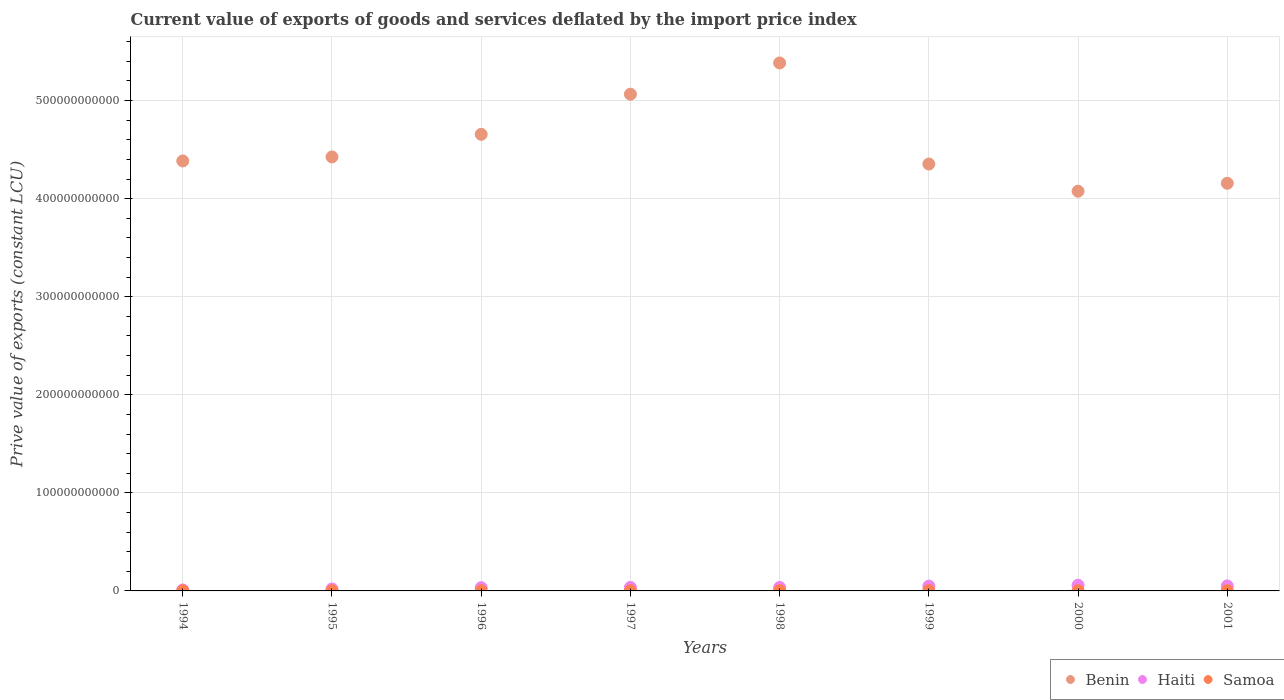How many different coloured dotlines are there?
Offer a terse response. 3. Is the number of dotlines equal to the number of legend labels?
Provide a short and direct response. Yes. What is the prive value of exports in Benin in 1999?
Your answer should be compact. 4.35e+11. Across all years, what is the maximum prive value of exports in Benin?
Make the answer very short. 5.38e+11. Across all years, what is the minimum prive value of exports in Benin?
Ensure brevity in your answer.  4.08e+11. In which year was the prive value of exports in Samoa minimum?
Offer a very short reply. 1994. What is the total prive value of exports in Samoa in the graph?
Provide a short and direct response. 1.95e+09. What is the difference between the prive value of exports in Benin in 1998 and that in 2000?
Provide a short and direct response. 1.31e+11. What is the difference between the prive value of exports in Haiti in 1999 and the prive value of exports in Benin in 1996?
Your answer should be compact. -4.61e+11. What is the average prive value of exports in Haiti per year?
Your answer should be compact. 3.65e+09. In the year 1994, what is the difference between the prive value of exports in Samoa and prive value of exports in Haiti?
Offer a terse response. -8.35e+08. In how many years, is the prive value of exports in Haiti greater than 440000000000 LCU?
Provide a succinct answer. 0. What is the ratio of the prive value of exports in Benin in 1998 to that in 2001?
Ensure brevity in your answer.  1.3. Is the prive value of exports in Samoa in 1997 less than that in 1998?
Ensure brevity in your answer.  Yes. Is the difference between the prive value of exports in Samoa in 1996 and 2000 greater than the difference between the prive value of exports in Haiti in 1996 and 2000?
Give a very brief answer. Yes. What is the difference between the highest and the second highest prive value of exports in Samoa?
Provide a short and direct response. 9.18e+06. What is the difference between the highest and the lowest prive value of exports in Haiti?
Give a very brief answer. 4.82e+09. Is the sum of the prive value of exports in Benin in 1998 and 2000 greater than the maximum prive value of exports in Haiti across all years?
Offer a very short reply. Yes. Does the prive value of exports in Samoa monotonically increase over the years?
Your answer should be compact. No. Is the prive value of exports in Samoa strictly greater than the prive value of exports in Benin over the years?
Your answer should be very brief. No. How many years are there in the graph?
Provide a succinct answer. 8. What is the difference between two consecutive major ticks on the Y-axis?
Offer a very short reply. 1.00e+11. Are the values on the major ticks of Y-axis written in scientific E-notation?
Give a very brief answer. No. Where does the legend appear in the graph?
Ensure brevity in your answer.  Bottom right. What is the title of the graph?
Your answer should be compact. Current value of exports of goods and services deflated by the import price index. What is the label or title of the X-axis?
Ensure brevity in your answer.  Years. What is the label or title of the Y-axis?
Offer a very short reply. Prive value of exports (constant LCU). What is the Prive value of exports (constant LCU) of Benin in 1994?
Offer a very short reply. 4.38e+11. What is the Prive value of exports (constant LCU) in Haiti in 1994?
Your answer should be very brief. 9.75e+08. What is the Prive value of exports (constant LCU) of Samoa in 1994?
Make the answer very short. 1.40e+08. What is the Prive value of exports (constant LCU) of Benin in 1995?
Make the answer very short. 4.43e+11. What is the Prive value of exports (constant LCU) of Haiti in 1995?
Your response must be concise. 2.02e+09. What is the Prive value of exports (constant LCU) of Samoa in 1995?
Your response must be concise. 2.05e+08. What is the Prive value of exports (constant LCU) of Benin in 1996?
Offer a terse response. 4.66e+11. What is the Prive value of exports (constant LCU) in Haiti in 1996?
Your answer should be very brief. 3.30e+09. What is the Prive value of exports (constant LCU) of Samoa in 1996?
Keep it short and to the point. 2.34e+08. What is the Prive value of exports (constant LCU) in Benin in 1997?
Your answer should be compact. 5.07e+11. What is the Prive value of exports (constant LCU) of Haiti in 1997?
Make the answer very short. 3.57e+09. What is the Prive value of exports (constant LCU) in Samoa in 1997?
Your answer should be very brief. 2.44e+08. What is the Prive value of exports (constant LCU) in Benin in 1998?
Your response must be concise. 5.38e+11. What is the Prive value of exports (constant LCU) of Haiti in 1998?
Make the answer very short. 3.58e+09. What is the Prive value of exports (constant LCU) of Samoa in 1998?
Keep it short and to the point. 2.86e+08. What is the Prive value of exports (constant LCU) of Benin in 1999?
Offer a terse response. 4.35e+11. What is the Prive value of exports (constant LCU) in Haiti in 1999?
Offer a terse response. 4.87e+09. What is the Prive value of exports (constant LCU) of Samoa in 1999?
Keep it short and to the point. 2.95e+08. What is the Prive value of exports (constant LCU) of Benin in 2000?
Make the answer very short. 4.08e+11. What is the Prive value of exports (constant LCU) of Haiti in 2000?
Provide a succinct answer. 5.79e+09. What is the Prive value of exports (constant LCU) of Samoa in 2000?
Offer a very short reply. 2.60e+08. What is the Prive value of exports (constant LCU) of Benin in 2001?
Your response must be concise. 4.16e+11. What is the Prive value of exports (constant LCU) of Haiti in 2001?
Give a very brief answer. 5.11e+09. What is the Prive value of exports (constant LCU) of Samoa in 2001?
Offer a very short reply. 2.85e+08. Across all years, what is the maximum Prive value of exports (constant LCU) of Benin?
Offer a terse response. 5.38e+11. Across all years, what is the maximum Prive value of exports (constant LCU) in Haiti?
Offer a very short reply. 5.79e+09. Across all years, what is the maximum Prive value of exports (constant LCU) in Samoa?
Keep it short and to the point. 2.95e+08. Across all years, what is the minimum Prive value of exports (constant LCU) in Benin?
Ensure brevity in your answer.  4.08e+11. Across all years, what is the minimum Prive value of exports (constant LCU) in Haiti?
Provide a short and direct response. 9.75e+08. Across all years, what is the minimum Prive value of exports (constant LCU) of Samoa?
Your response must be concise. 1.40e+08. What is the total Prive value of exports (constant LCU) of Benin in the graph?
Keep it short and to the point. 3.65e+12. What is the total Prive value of exports (constant LCU) of Haiti in the graph?
Your response must be concise. 2.92e+1. What is the total Prive value of exports (constant LCU) of Samoa in the graph?
Provide a succinct answer. 1.95e+09. What is the difference between the Prive value of exports (constant LCU) in Benin in 1994 and that in 1995?
Offer a very short reply. -4.11e+09. What is the difference between the Prive value of exports (constant LCU) of Haiti in 1994 and that in 1995?
Keep it short and to the point. -1.04e+09. What is the difference between the Prive value of exports (constant LCU) in Samoa in 1994 and that in 1995?
Provide a succinct answer. -6.46e+07. What is the difference between the Prive value of exports (constant LCU) of Benin in 1994 and that in 1996?
Provide a succinct answer. -2.72e+1. What is the difference between the Prive value of exports (constant LCU) in Haiti in 1994 and that in 1996?
Provide a succinct answer. -2.32e+09. What is the difference between the Prive value of exports (constant LCU) of Samoa in 1994 and that in 1996?
Your answer should be compact. -9.42e+07. What is the difference between the Prive value of exports (constant LCU) in Benin in 1994 and that in 1997?
Keep it short and to the point. -6.81e+1. What is the difference between the Prive value of exports (constant LCU) of Haiti in 1994 and that in 1997?
Make the answer very short. -2.59e+09. What is the difference between the Prive value of exports (constant LCU) in Samoa in 1994 and that in 1997?
Offer a very short reply. -1.04e+08. What is the difference between the Prive value of exports (constant LCU) in Benin in 1994 and that in 1998?
Your response must be concise. -9.99e+1. What is the difference between the Prive value of exports (constant LCU) in Haiti in 1994 and that in 1998?
Keep it short and to the point. -2.60e+09. What is the difference between the Prive value of exports (constant LCU) in Samoa in 1994 and that in 1998?
Give a very brief answer. -1.46e+08. What is the difference between the Prive value of exports (constant LCU) of Benin in 1994 and that in 1999?
Offer a very short reply. 3.13e+09. What is the difference between the Prive value of exports (constant LCU) in Haiti in 1994 and that in 1999?
Make the answer very short. -3.89e+09. What is the difference between the Prive value of exports (constant LCU) in Samoa in 1994 and that in 1999?
Your answer should be very brief. -1.55e+08. What is the difference between the Prive value of exports (constant LCU) of Benin in 1994 and that in 2000?
Your answer should be compact. 3.09e+1. What is the difference between the Prive value of exports (constant LCU) in Haiti in 1994 and that in 2000?
Provide a succinct answer. -4.82e+09. What is the difference between the Prive value of exports (constant LCU) in Samoa in 1994 and that in 2000?
Make the answer very short. -1.20e+08. What is the difference between the Prive value of exports (constant LCU) of Benin in 1994 and that in 2001?
Provide a succinct answer. 2.28e+1. What is the difference between the Prive value of exports (constant LCU) in Haiti in 1994 and that in 2001?
Ensure brevity in your answer.  -4.13e+09. What is the difference between the Prive value of exports (constant LCU) in Samoa in 1994 and that in 2001?
Your answer should be compact. -1.45e+08. What is the difference between the Prive value of exports (constant LCU) in Benin in 1995 and that in 1996?
Your response must be concise. -2.30e+1. What is the difference between the Prive value of exports (constant LCU) of Haiti in 1995 and that in 1996?
Ensure brevity in your answer.  -1.28e+09. What is the difference between the Prive value of exports (constant LCU) of Samoa in 1995 and that in 1996?
Your answer should be compact. -2.96e+07. What is the difference between the Prive value of exports (constant LCU) in Benin in 1995 and that in 1997?
Offer a very short reply. -6.40e+1. What is the difference between the Prive value of exports (constant LCU) in Haiti in 1995 and that in 1997?
Provide a short and direct response. -1.55e+09. What is the difference between the Prive value of exports (constant LCU) in Samoa in 1995 and that in 1997?
Provide a succinct answer. -3.93e+07. What is the difference between the Prive value of exports (constant LCU) in Benin in 1995 and that in 1998?
Your response must be concise. -9.58e+1. What is the difference between the Prive value of exports (constant LCU) in Haiti in 1995 and that in 1998?
Your response must be concise. -1.56e+09. What is the difference between the Prive value of exports (constant LCU) in Samoa in 1995 and that in 1998?
Ensure brevity in your answer.  -8.15e+07. What is the difference between the Prive value of exports (constant LCU) in Benin in 1995 and that in 1999?
Provide a short and direct response. 7.24e+09. What is the difference between the Prive value of exports (constant LCU) of Haiti in 1995 and that in 1999?
Give a very brief answer. -2.85e+09. What is the difference between the Prive value of exports (constant LCU) in Samoa in 1995 and that in 1999?
Make the answer very short. -9.07e+07. What is the difference between the Prive value of exports (constant LCU) of Benin in 1995 and that in 2000?
Offer a very short reply. 3.50e+1. What is the difference between the Prive value of exports (constant LCU) of Haiti in 1995 and that in 2000?
Offer a terse response. -3.78e+09. What is the difference between the Prive value of exports (constant LCU) in Samoa in 1995 and that in 2000?
Your answer should be very brief. -5.55e+07. What is the difference between the Prive value of exports (constant LCU) in Benin in 1995 and that in 2001?
Your response must be concise. 2.69e+1. What is the difference between the Prive value of exports (constant LCU) of Haiti in 1995 and that in 2001?
Make the answer very short. -3.09e+09. What is the difference between the Prive value of exports (constant LCU) of Samoa in 1995 and that in 2001?
Ensure brevity in your answer.  -8.03e+07. What is the difference between the Prive value of exports (constant LCU) in Benin in 1996 and that in 1997?
Your answer should be compact. -4.09e+1. What is the difference between the Prive value of exports (constant LCU) in Haiti in 1996 and that in 1997?
Make the answer very short. -2.68e+08. What is the difference between the Prive value of exports (constant LCU) in Samoa in 1996 and that in 1997?
Your answer should be compact. -9.63e+06. What is the difference between the Prive value of exports (constant LCU) of Benin in 1996 and that in 1998?
Your answer should be very brief. -7.28e+1. What is the difference between the Prive value of exports (constant LCU) in Haiti in 1996 and that in 1998?
Your response must be concise. -2.78e+08. What is the difference between the Prive value of exports (constant LCU) in Samoa in 1996 and that in 1998?
Keep it short and to the point. -5.19e+07. What is the difference between the Prive value of exports (constant LCU) of Benin in 1996 and that in 1999?
Offer a terse response. 3.03e+1. What is the difference between the Prive value of exports (constant LCU) of Haiti in 1996 and that in 1999?
Your answer should be very brief. -1.57e+09. What is the difference between the Prive value of exports (constant LCU) in Samoa in 1996 and that in 1999?
Offer a terse response. -6.11e+07. What is the difference between the Prive value of exports (constant LCU) of Benin in 1996 and that in 2000?
Your response must be concise. 5.80e+1. What is the difference between the Prive value of exports (constant LCU) in Haiti in 1996 and that in 2000?
Offer a terse response. -2.50e+09. What is the difference between the Prive value of exports (constant LCU) of Samoa in 1996 and that in 2000?
Your answer should be very brief. -2.59e+07. What is the difference between the Prive value of exports (constant LCU) of Benin in 1996 and that in 2001?
Give a very brief answer. 4.99e+1. What is the difference between the Prive value of exports (constant LCU) in Haiti in 1996 and that in 2001?
Give a very brief answer. -1.81e+09. What is the difference between the Prive value of exports (constant LCU) of Samoa in 1996 and that in 2001?
Provide a short and direct response. -5.07e+07. What is the difference between the Prive value of exports (constant LCU) in Benin in 1997 and that in 1998?
Your response must be concise. -3.19e+1. What is the difference between the Prive value of exports (constant LCU) of Haiti in 1997 and that in 1998?
Provide a succinct answer. -1.03e+07. What is the difference between the Prive value of exports (constant LCU) of Samoa in 1997 and that in 1998?
Give a very brief answer. -4.23e+07. What is the difference between the Prive value of exports (constant LCU) in Benin in 1997 and that in 1999?
Offer a terse response. 7.12e+1. What is the difference between the Prive value of exports (constant LCU) in Haiti in 1997 and that in 1999?
Offer a very short reply. -1.30e+09. What is the difference between the Prive value of exports (constant LCU) of Samoa in 1997 and that in 1999?
Offer a terse response. -5.15e+07. What is the difference between the Prive value of exports (constant LCU) of Benin in 1997 and that in 2000?
Your response must be concise. 9.89e+1. What is the difference between the Prive value of exports (constant LCU) of Haiti in 1997 and that in 2000?
Provide a succinct answer. -2.23e+09. What is the difference between the Prive value of exports (constant LCU) of Samoa in 1997 and that in 2000?
Ensure brevity in your answer.  -1.63e+07. What is the difference between the Prive value of exports (constant LCU) in Benin in 1997 and that in 2001?
Provide a succinct answer. 9.08e+1. What is the difference between the Prive value of exports (constant LCU) in Haiti in 1997 and that in 2001?
Make the answer very short. -1.54e+09. What is the difference between the Prive value of exports (constant LCU) in Samoa in 1997 and that in 2001?
Make the answer very short. -4.10e+07. What is the difference between the Prive value of exports (constant LCU) in Benin in 1998 and that in 1999?
Offer a very short reply. 1.03e+11. What is the difference between the Prive value of exports (constant LCU) in Haiti in 1998 and that in 1999?
Offer a terse response. -1.29e+09. What is the difference between the Prive value of exports (constant LCU) of Samoa in 1998 and that in 1999?
Offer a terse response. -9.18e+06. What is the difference between the Prive value of exports (constant LCU) in Benin in 1998 and that in 2000?
Your response must be concise. 1.31e+11. What is the difference between the Prive value of exports (constant LCU) in Haiti in 1998 and that in 2000?
Your answer should be compact. -2.22e+09. What is the difference between the Prive value of exports (constant LCU) of Samoa in 1998 and that in 2000?
Make the answer very short. 2.60e+07. What is the difference between the Prive value of exports (constant LCU) of Benin in 1998 and that in 2001?
Offer a terse response. 1.23e+11. What is the difference between the Prive value of exports (constant LCU) in Haiti in 1998 and that in 2001?
Provide a succinct answer. -1.53e+09. What is the difference between the Prive value of exports (constant LCU) of Samoa in 1998 and that in 2001?
Your answer should be very brief. 1.26e+06. What is the difference between the Prive value of exports (constant LCU) in Benin in 1999 and that in 2000?
Your answer should be very brief. 2.77e+1. What is the difference between the Prive value of exports (constant LCU) of Haiti in 1999 and that in 2000?
Provide a succinct answer. -9.28e+08. What is the difference between the Prive value of exports (constant LCU) of Samoa in 1999 and that in 2000?
Provide a short and direct response. 3.52e+07. What is the difference between the Prive value of exports (constant LCU) of Benin in 1999 and that in 2001?
Provide a short and direct response. 1.96e+1. What is the difference between the Prive value of exports (constant LCU) of Haiti in 1999 and that in 2001?
Offer a terse response. -2.42e+08. What is the difference between the Prive value of exports (constant LCU) of Samoa in 1999 and that in 2001?
Make the answer very short. 1.04e+07. What is the difference between the Prive value of exports (constant LCU) in Benin in 2000 and that in 2001?
Your answer should be very brief. -8.10e+09. What is the difference between the Prive value of exports (constant LCU) in Haiti in 2000 and that in 2001?
Provide a short and direct response. 6.86e+08. What is the difference between the Prive value of exports (constant LCU) in Samoa in 2000 and that in 2001?
Offer a terse response. -2.48e+07. What is the difference between the Prive value of exports (constant LCU) of Benin in 1994 and the Prive value of exports (constant LCU) of Haiti in 1995?
Offer a very short reply. 4.36e+11. What is the difference between the Prive value of exports (constant LCU) in Benin in 1994 and the Prive value of exports (constant LCU) in Samoa in 1995?
Ensure brevity in your answer.  4.38e+11. What is the difference between the Prive value of exports (constant LCU) in Haiti in 1994 and the Prive value of exports (constant LCU) in Samoa in 1995?
Keep it short and to the point. 7.70e+08. What is the difference between the Prive value of exports (constant LCU) in Benin in 1994 and the Prive value of exports (constant LCU) in Haiti in 1996?
Offer a terse response. 4.35e+11. What is the difference between the Prive value of exports (constant LCU) in Benin in 1994 and the Prive value of exports (constant LCU) in Samoa in 1996?
Give a very brief answer. 4.38e+11. What is the difference between the Prive value of exports (constant LCU) of Haiti in 1994 and the Prive value of exports (constant LCU) of Samoa in 1996?
Provide a short and direct response. 7.40e+08. What is the difference between the Prive value of exports (constant LCU) of Benin in 1994 and the Prive value of exports (constant LCU) of Haiti in 1997?
Keep it short and to the point. 4.35e+11. What is the difference between the Prive value of exports (constant LCU) in Benin in 1994 and the Prive value of exports (constant LCU) in Samoa in 1997?
Provide a succinct answer. 4.38e+11. What is the difference between the Prive value of exports (constant LCU) in Haiti in 1994 and the Prive value of exports (constant LCU) in Samoa in 1997?
Keep it short and to the point. 7.31e+08. What is the difference between the Prive value of exports (constant LCU) of Benin in 1994 and the Prive value of exports (constant LCU) of Haiti in 1998?
Provide a succinct answer. 4.35e+11. What is the difference between the Prive value of exports (constant LCU) of Benin in 1994 and the Prive value of exports (constant LCU) of Samoa in 1998?
Ensure brevity in your answer.  4.38e+11. What is the difference between the Prive value of exports (constant LCU) in Haiti in 1994 and the Prive value of exports (constant LCU) in Samoa in 1998?
Your response must be concise. 6.88e+08. What is the difference between the Prive value of exports (constant LCU) of Benin in 1994 and the Prive value of exports (constant LCU) of Haiti in 1999?
Your answer should be compact. 4.34e+11. What is the difference between the Prive value of exports (constant LCU) in Benin in 1994 and the Prive value of exports (constant LCU) in Samoa in 1999?
Provide a short and direct response. 4.38e+11. What is the difference between the Prive value of exports (constant LCU) of Haiti in 1994 and the Prive value of exports (constant LCU) of Samoa in 1999?
Provide a succinct answer. 6.79e+08. What is the difference between the Prive value of exports (constant LCU) of Benin in 1994 and the Prive value of exports (constant LCU) of Haiti in 2000?
Provide a short and direct response. 4.33e+11. What is the difference between the Prive value of exports (constant LCU) in Benin in 1994 and the Prive value of exports (constant LCU) in Samoa in 2000?
Make the answer very short. 4.38e+11. What is the difference between the Prive value of exports (constant LCU) of Haiti in 1994 and the Prive value of exports (constant LCU) of Samoa in 2000?
Make the answer very short. 7.14e+08. What is the difference between the Prive value of exports (constant LCU) in Benin in 1994 and the Prive value of exports (constant LCU) in Haiti in 2001?
Offer a very short reply. 4.33e+11. What is the difference between the Prive value of exports (constant LCU) of Benin in 1994 and the Prive value of exports (constant LCU) of Samoa in 2001?
Give a very brief answer. 4.38e+11. What is the difference between the Prive value of exports (constant LCU) in Haiti in 1994 and the Prive value of exports (constant LCU) in Samoa in 2001?
Provide a succinct answer. 6.90e+08. What is the difference between the Prive value of exports (constant LCU) of Benin in 1995 and the Prive value of exports (constant LCU) of Haiti in 1996?
Provide a short and direct response. 4.39e+11. What is the difference between the Prive value of exports (constant LCU) of Benin in 1995 and the Prive value of exports (constant LCU) of Samoa in 1996?
Ensure brevity in your answer.  4.42e+11. What is the difference between the Prive value of exports (constant LCU) of Haiti in 1995 and the Prive value of exports (constant LCU) of Samoa in 1996?
Provide a short and direct response. 1.78e+09. What is the difference between the Prive value of exports (constant LCU) in Benin in 1995 and the Prive value of exports (constant LCU) in Haiti in 1997?
Your answer should be compact. 4.39e+11. What is the difference between the Prive value of exports (constant LCU) of Benin in 1995 and the Prive value of exports (constant LCU) of Samoa in 1997?
Your answer should be very brief. 4.42e+11. What is the difference between the Prive value of exports (constant LCU) of Haiti in 1995 and the Prive value of exports (constant LCU) of Samoa in 1997?
Offer a terse response. 1.77e+09. What is the difference between the Prive value of exports (constant LCU) of Benin in 1995 and the Prive value of exports (constant LCU) of Haiti in 1998?
Give a very brief answer. 4.39e+11. What is the difference between the Prive value of exports (constant LCU) in Benin in 1995 and the Prive value of exports (constant LCU) in Samoa in 1998?
Make the answer very short. 4.42e+11. What is the difference between the Prive value of exports (constant LCU) of Haiti in 1995 and the Prive value of exports (constant LCU) of Samoa in 1998?
Your answer should be compact. 1.73e+09. What is the difference between the Prive value of exports (constant LCU) in Benin in 1995 and the Prive value of exports (constant LCU) in Haiti in 1999?
Your answer should be compact. 4.38e+11. What is the difference between the Prive value of exports (constant LCU) of Benin in 1995 and the Prive value of exports (constant LCU) of Samoa in 1999?
Keep it short and to the point. 4.42e+11. What is the difference between the Prive value of exports (constant LCU) in Haiti in 1995 and the Prive value of exports (constant LCU) in Samoa in 1999?
Give a very brief answer. 1.72e+09. What is the difference between the Prive value of exports (constant LCU) of Benin in 1995 and the Prive value of exports (constant LCU) of Haiti in 2000?
Keep it short and to the point. 4.37e+11. What is the difference between the Prive value of exports (constant LCU) of Benin in 1995 and the Prive value of exports (constant LCU) of Samoa in 2000?
Give a very brief answer. 4.42e+11. What is the difference between the Prive value of exports (constant LCU) in Haiti in 1995 and the Prive value of exports (constant LCU) in Samoa in 2000?
Give a very brief answer. 1.76e+09. What is the difference between the Prive value of exports (constant LCU) in Benin in 1995 and the Prive value of exports (constant LCU) in Haiti in 2001?
Your response must be concise. 4.37e+11. What is the difference between the Prive value of exports (constant LCU) in Benin in 1995 and the Prive value of exports (constant LCU) in Samoa in 2001?
Ensure brevity in your answer.  4.42e+11. What is the difference between the Prive value of exports (constant LCU) in Haiti in 1995 and the Prive value of exports (constant LCU) in Samoa in 2001?
Your answer should be very brief. 1.73e+09. What is the difference between the Prive value of exports (constant LCU) of Benin in 1996 and the Prive value of exports (constant LCU) of Haiti in 1997?
Offer a very short reply. 4.62e+11. What is the difference between the Prive value of exports (constant LCU) of Benin in 1996 and the Prive value of exports (constant LCU) of Samoa in 1997?
Your answer should be very brief. 4.65e+11. What is the difference between the Prive value of exports (constant LCU) in Haiti in 1996 and the Prive value of exports (constant LCU) in Samoa in 1997?
Provide a succinct answer. 3.05e+09. What is the difference between the Prive value of exports (constant LCU) in Benin in 1996 and the Prive value of exports (constant LCU) in Haiti in 1998?
Ensure brevity in your answer.  4.62e+11. What is the difference between the Prive value of exports (constant LCU) in Benin in 1996 and the Prive value of exports (constant LCU) in Samoa in 1998?
Your answer should be very brief. 4.65e+11. What is the difference between the Prive value of exports (constant LCU) in Haiti in 1996 and the Prive value of exports (constant LCU) in Samoa in 1998?
Ensure brevity in your answer.  3.01e+09. What is the difference between the Prive value of exports (constant LCU) of Benin in 1996 and the Prive value of exports (constant LCU) of Haiti in 1999?
Offer a very short reply. 4.61e+11. What is the difference between the Prive value of exports (constant LCU) in Benin in 1996 and the Prive value of exports (constant LCU) in Samoa in 1999?
Provide a short and direct response. 4.65e+11. What is the difference between the Prive value of exports (constant LCU) in Haiti in 1996 and the Prive value of exports (constant LCU) in Samoa in 1999?
Provide a short and direct response. 3.00e+09. What is the difference between the Prive value of exports (constant LCU) of Benin in 1996 and the Prive value of exports (constant LCU) of Haiti in 2000?
Offer a very short reply. 4.60e+11. What is the difference between the Prive value of exports (constant LCU) of Benin in 1996 and the Prive value of exports (constant LCU) of Samoa in 2000?
Keep it short and to the point. 4.65e+11. What is the difference between the Prive value of exports (constant LCU) of Haiti in 1996 and the Prive value of exports (constant LCU) of Samoa in 2000?
Ensure brevity in your answer.  3.04e+09. What is the difference between the Prive value of exports (constant LCU) in Benin in 1996 and the Prive value of exports (constant LCU) in Haiti in 2001?
Make the answer very short. 4.60e+11. What is the difference between the Prive value of exports (constant LCU) of Benin in 1996 and the Prive value of exports (constant LCU) of Samoa in 2001?
Ensure brevity in your answer.  4.65e+11. What is the difference between the Prive value of exports (constant LCU) in Haiti in 1996 and the Prive value of exports (constant LCU) in Samoa in 2001?
Offer a very short reply. 3.01e+09. What is the difference between the Prive value of exports (constant LCU) in Benin in 1997 and the Prive value of exports (constant LCU) in Haiti in 1998?
Give a very brief answer. 5.03e+11. What is the difference between the Prive value of exports (constant LCU) of Benin in 1997 and the Prive value of exports (constant LCU) of Samoa in 1998?
Make the answer very short. 5.06e+11. What is the difference between the Prive value of exports (constant LCU) in Haiti in 1997 and the Prive value of exports (constant LCU) in Samoa in 1998?
Offer a very short reply. 3.28e+09. What is the difference between the Prive value of exports (constant LCU) in Benin in 1997 and the Prive value of exports (constant LCU) in Haiti in 1999?
Keep it short and to the point. 5.02e+11. What is the difference between the Prive value of exports (constant LCU) of Benin in 1997 and the Prive value of exports (constant LCU) of Samoa in 1999?
Provide a short and direct response. 5.06e+11. What is the difference between the Prive value of exports (constant LCU) in Haiti in 1997 and the Prive value of exports (constant LCU) in Samoa in 1999?
Provide a succinct answer. 3.27e+09. What is the difference between the Prive value of exports (constant LCU) in Benin in 1997 and the Prive value of exports (constant LCU) in Haiti in 2000?
Your response must be concise. 5.01e+11. What is the difference between the Prive value of exports (constant LCU) in Benin in 1997 and the Prive value of exports (constant LCU) in Samoa in 2000?
Your response must be concise. 5.06e+11. What is the difference between the Prive value of exports (constant LCU) in Haiti in 1997 and the Prive value of exports (constant LCU) in Samoa in 2000?
Provide a succinct answer. 3.31e+09. What is the difference between the Prive value of exports (constant LCU) in Benin in 1997 and the Prive value of exports (constant LCU) in Haiti in 2001?
Offer a very short reply. 5.01e+11. What is the difference between the Prive value of exports (constant LCU) of Benin in 1997 and the Prive value of exports (constant LCU) of Samoa in 2001?
Provide a short and direct response. 5.06e+11. What is the difference between the Prive value of exports (constant LCU) in Haiti in 1997 and the Prive value of exports (constant LCU) in Samoa in 2001?
Your answer should be very brief. 3.28e+09. What is the difference between the Prive value of exports (constant LCU) of Benin in 1998 and the Prive value of exports (constant LCU) of Haiti in 1999?
Provide a succinct answer. 5.33e+11. What is the difference between the Prive value of exports (constant LCU) of Benin in 1998 and the Prive value of exports (constant LCU) of Samoa in 1999?
Your response must be concise. 5.38e+11. What is the difference between the Prive value of exports (constant LCU) of Haiti in 1998 and the Prive value of exports (constant LCU) of Samoa in 1999?
Offer a terse response. 3.28e+09. What is the difference between the Prive value of exports (constant LCU) in Benin in 1998 and the Prive value of exports (constant LCU) in Haiti in 2000?
Provide a short and direct response. 5.33e+11. What is the difference between the Prive value of exports (constant LCU) in Benin in 1998 and the Prive value of exports (constant LCU) in Samoa in 2000?
Keep it short and to the point. 5.38e+11. What is the difference between the Prive value of exports (constant LCU) of Haiti in 1998 and the Prive value of exports (constant LCU) of Samoa in 2000?
Provide a succinct answer. 3.32e+09. What is the difference between the Prive value of exports (constant LCU) in Benin in 1998 and the Prive value of exports (constant LCU) in Haiti in 2001?
Make the answer very short. 5.33e+11. What is the difference between the Prive value of exports (constant LCU) in Benin in 1998 and the Prive value of exports (constant LCU) in Samoa in 2001?
Provide a short and direct response. 5.38e+11. What is the difference between the Prive value of exports (constant LCU) in Haiti in 1998 and the Prive value of exports (constant LCU) in Samoa in 2001?
Make the answer very short. 3.29e+09. What is the difference between the Prive value of exports (constant LCU) of Benin in 1999 and the Prive value of exports (constant LCU) of Haiti in 2000?
Provide a succinct answer. 4.30e+11. What is the difference between the Prive value of exports (constant LCU) in Benin in 1999 and the Prive value of exports (constant LCU) in Samoa in 2000?
Ensure brevity in your answer.  4.35e+11. What is the difference between the Prive value of exports (constant LCU) of Haiti in 1999 and the Prive value of exports (constant LCU) of Samoa in 2000?
Provide a short and direct response. 4.61e+09. What is the difference between the Prive value of exports (constant LCU) of Benin in 1999 and the Prive value of exports (constant LCU) of Haiti in 2001?
Offer a very short reply. 4.30e+11. What is the difference between the Prive value of exports (constant LCU) of Benin in 1999 and the Prive value of exports (constant LCU) of Samoa in 2001?
Provide a short and direct response. 4.35e+11. What is the difference between the Prive value of exports (constant LCU) in Haiti in 1999 and the Prive value of exports (constant LCU) in Samoa in 2001?
Make the answer very short. 4.58e+09. What is the difference between the Prive value of exports (constant LCU) of Benin in 2000 and the Prive value of exports (constant LCU) of Haiti in 2001?
Your response must be concise. 4.02e+11. What is the difference between the Prive value of exports (constant LCU) of Benin in 2000 and the Prive value of exports (constant LCU) of Samoa in 2001?
Provide a succinct answer. 4.07e+11. What is the difference between the Prive value of exports (constant LCU) of Haiti in 2000 and the Prive value of exports (constant LCU) of Samoa in 2001?
Your answer should be very brief. 5.51e+09. What is the average Prive value of exports (constant LCU) of Benin per year?
Your answer should be compact. 4.56e+11. What is the average Prive value of exports (constant LCU) in Haiti per year?
Your answer should be very brief. 3.65e+09. What is the average Prive value of exports (constant LCU) in Samoa per year?
Offer a very short reply. 2.44e+08. In the year 1994, what is the difference between the Prive value of exports (constant LCU) in Benin and Prive value of exports (constant LCU) in Haiti?
Keep it short and to the point. 4.37e+11. In the year 1994, what is the difference between the Prive value of exports (constant LCU) of Benin and Prive value of exports (constant LCU) of Samoa?
Keep it short and to the point. 4.38e+11. In the year 1994, what is the difference between the Prive value of exports (constant LCU) in Haiti and Prive value of exports (constant LCU) in Samoa?
Give a very brief answer. 8.35e+08. In the year 1995, what is the difference between the Prive value of exports (constant LCU) in Benin and Prive value of exports (constant LCU) in Haiti?
Give a very brief answer. 4.41e+11. In the year 1995, what is the difference between the Prive value of exports (constant LCU) of Benin and Prive value of exports (constant LCU) of Samoa?
Offer a very short reply. 4.42e+11. In the year 1995, what is the difference between the Prive value of exports (constant LCU) in Haiti and Prive value of exports (constant LCU) in Samoa?
Offer a terse response. 1.81e+09. In the year 1996, what is the difference between the Prive value of exports (constant LCU) of Benin and Prive value of exports (constant LCU) of Haiti?
Your answer should be very brief. 4.62e+11. In the year 1996, what is the difference between the Prive value of exports (constant LCU) of Benin and Prive value of exports (constant LCU) of Samoa?
Your response must be concise. 4.65e+11. In the year 1996, what is the difference between the Prive value of exports (constant LCU) of Haiti and Prive value of exports (constant LCU) of Samoa?
Keep it short and to the point. 3.06e+09. In the year 1997, what is the difference between the Prive value of exports (constant LCU) in Benin and Prive value of exports (constant LCU) in Haiti?
Provide a succinct answer. 5.03e+11. In the year 1997, what is the difference between the Prive value of exports (constant LCU) in Benin and Prive value of exports (constant LCU) in Samoa?
Your response must be concise. 5.06e+11. In the year 1997, what is the difference between the Prive value of exports (constant LCU) of Haiti and Prive value of exports (constant LCU) of Samoa?
Ensure brevity in your answer.  3.32e+09. In the year 1998, what is the difference between the Prive value of exports (constant LCU) in Benin and Prive value of exports (constant LCU) in Haiti?
Your answer should be very brief. 5.35e+11. In the year 1998, what is the difference between the Prive value of exports (constant LCU) in Benin and Prive value of exports (constant LCU) in Samoa?
Provide a short and direct response. 5.38e+11. In the year 1998, what is the difference between the Prive value of exports (constant LCU) in Haiti and Prive value of exports (constant LCU) in Samoa?
Make the answer very short. 3.29e+09. In the year 1999, what is the difference between the Prive value of exports (constant LCU) in Benin and Prive value of exports (constant LCU) in Haiti?
Your response must be concise. 4.30e+11. In the year 1999, what is the difference between the Prive value of exports (constant LCU) in Benin and Prive value of exports (constant LCU) in Samoa?
Keep it short and to the point. 4.35e+11. In the year 1999, what is the difference between the Prive value of exports (constant LCU) of Haiti and Prive value of exports (constant LCU) of Samoa?
Keep it short and to the point. 4.57e+09. In the year 2000, what is the difference between the Prive value of exports (constant LCU) of Benin and Prive value of exports (constant LCU) of Haiti?
Offer a terse response. 4.02e+11. In the year 2000, what is the difference between the Prive value of exports (constant LCU) of Benin and Prive value of exports (constant LCU) of Samoa?
Offer a terse response. 4.07e+11. In the year 2000, what is the difference between the Prive value of exports (constant LCU) of Haiti and Prive value of exports (constant LCU) of Samoa?
Your response must be concise. 5.53e+09. In the year 2001, what is the difference between the Prive value of exports (constant LCU) in Benin and Prive value of exports (constant LCU) in Haiti?
Keep it short and to the point. 4.11e+11. In the year 2001, what is the difference between the Prive value of exports (constant LCU) in Benin and Prive value of exports (constant LCU) in Samoa?
Give a very brief answer. 4.15e+11. In the year 2001, what is the difference between the Prive value of exports (constant LCU) in Haiti and Prive value of exports (constant LCU) in Samoa?
Make the answer very short. 4.82e+09. What is the ratio of the Prive value of exports (constant LCU) of Benin in 1994 to that in 1995?
Provide a succinct answer. 0.99. What is the ratio of the Prive value of exports (constant LCU) of Haiti in 1994 to that in 1995?
Your answer should be very brief. 0.48. What is the ratio of the Prive value of exports (constant LCU) of Samoa in 1994 to that in 1995?
Make the answer very short. 0.68. What is the ratio of the Prive value of exports (constant LCU) of Benin in 1994 to that in 1996?
Provide a succinct answer. 0.94. What is the ratio of the Prive value of exports (constant LCU) in Haiti in 1994 to that in 1996?
Your answer should be compact. 0.3. What is the ratio of the Prive value of exports (constant LCU) in Samoa in 1994 to that in 1996?
Keep it short and to the point. 0.6. What is the ratio of the Prive value of exports (constant LCU) in Benin in 1994 to that in 1997?
Your answer should be compact. 0.87. What is the ratio of the Prive value of exports (constant LCU) of Haiti in 1994 to that in 1997?
Offer a very short reply. 0.27. What is the ratio of the Prive value of exports (constant LCU) in Samoa in 1994 to that in 1997?
Provide a short and direct response. 0.57. What is the ratio of the Prive value of exports (constant LCU) in Benin in 1994 to that in 1998?
Provide a short and direct response. 0.81. What is the ratio of the Prive value of exports (constant LCU) in Haiti in 1994 to that in 1998?
Give a very brief answer. 0.27. What is the ratio of the Prive value of exports (constant LCU) in Samoa in 1994 to that in 1998?
Give a very brief answer. 0.49. What is the ratio of the Prive value of exports (constant LCU) of Haiti in 1994 to that in 1999?
Make the answer very short. 0.2. What is the ratio of the Prive value of exports (constant LCU) of Samoa in 1994 to that in 1999?
Provide a short and direct response. 0.47. What is the ratio of the Prive value of exports (constant LCU) in Benin in 1994 to that in 2000?
Provide a short and direct response. 1.08. What is the ratio of the Prive value of exports (constant LCU) of Haiti in 1994 to that in 2000?
Make the answer very short. 0.17. What is the ratio of the Prive value of exports (constant LCU) of Samoa in 1994 to that in 2000?
Keep it short and to the point. 0.54. What is the ratio of the Prive value of exports (constant LCU) of Benin in 1994 to that in 2001?
Give a very brief answer. 1.05. What is the ratio of the Prive value of exports (constant LCU) in Haiti in 1994 to that in 2001?
Your answer should be very brief. 0.19. What is the ratio of the Prive value of exports (constant LCU) in Samoa in 1994 to that in 2001?
Keep it short and to the point. 0.49. What is the ratio of the Prive value of exports (constant LCU) in Benin in 1995 to that in 1996?
Offer a very short reply. 0.95. What is the ratio of the Prive value of exports (constant LCU) in Haiti in 1995 to that in 1996?
Offer a very short reply. 0.61. What is the ratio of the Prive value of exports (constant LCU) of Samoa in 1995 to that in 1996?
Your answer should be compact. 0.87. What is the ratio of the Prive value of exports (constant LCU) in Benin in 1995 to that in 1997?
Your answer should be very brief. 0.87. What is the ratio of the Prive value of exports (constant LCU) in Haiti in 1995 to that in 1997?
Keep it short and to the point. 0.57. What is the ratio of the Prive value of exports (constant LCU) in Samoa in 1995 to that in 1997?
Offer a very short reply. 0.84. What is the ratio of the Prive value of exports (constant LCU) in Benin in 1995 to that in 1998?
Offer a terse response. 0.82. What is the ratio of the Prive value of exports (constant LCU) of Haiti in 1995 to that in 1998?
Give a very brief answer. 0.56. What is the ratio of the Prive value of exports (constant LCU) of Samoa in 1995 to that in 1998?
Provide a short and direct response. 0.72. What is the ratio of the Prive value of exports (constant LCU) in Benin in 1995 to that in 1999?
Provide a succinct answer. 1.02. What is the ratio of the Prive value of exports (constant LCU) in Haiti in 1995 to that in 1999?
Offer a terse response. 0.41. What is the ratio of the Prive value of exports (constant LCU) of Samoa in 1995 to that in 1999?
Ensure brevity in your answer.  0.69. What is the ratio of the Prive value of exports (constant LCU) of Benin in 1995 to that in 2000?
Provide a succinct answer. 1.09. What is the ratio of the Prive value of exports (constant LCU) of Haiti in 1995 to that in 2000?
Keep it short and to the point. 0.35. What is the ratio of the Prive value of exports (constant LCU) in Samoa in 1995 to that in 2000?
Your response must be concise. 0.79. What is the ratio of the Prive value of exports (constant LCU) of Benin in 1995 to that in 2001?
Offer a very short reply. 1.06. What is the ratio of the Prive value of exports (constant LCU) of Haiti in 1995 to that in 2001?
Your answer should be very brief. 0.4. What is the ratio of the Prive value of exports (constant LCU) in Samoa in 1995 to that in 2001?
Your answer should be compact. 0.72. What is the ratio of the Prive value of exports (constant LCU) of Benin in 1996 to that in 1997?
Your response must be concise. 0.92. What is the ratio of the Prive value of exports (constant LCU) of Haiti in 1996 to that in 1997?
Keep it short and to the point. 0.92. What is the ratio of the Prive value of exports (constant LCU) in Samoa in 1996 to that in 1997?
Your answer should be very brief. 0.96. What is the ratio of the Prive value of exports (constant LCU) of Benin in 1996 to that in 1998?
Provide a short and direct response. 0.86. What is the ratio of the Prive value of exports (constant LCU) of Haiti in 1996 to that in 1998?
Keep it short and to the point. 0.92. What is the ratio of the Prive value of exports (constant LCU) in Samoa in 1996 to that in 1998?
Your answer should be compact. 0.82. What is the ratio of the Prive value of exports (constant LCU) in Benin in 1996 to that in 1999?
Provide a short and direct response. 1.07. What is the ratio of the Prive value of exports (constant LCU) in Haiti in 1996 to that in 1999?
Give a very brief answer. 0.68. What is the ratio of the Prive value of exports (constant LCU) in Samoa in 1996 to that in 1999?
Your answer should be very brief. 0.79. What is the ratio of the Prive value of exports (constant LCU) of Benin in 1996 to that in 2000?
Your answer should be very brief. 1.14. What is the ratio of the Prive value of exports (constant LCU) of Haiti in 1996 to that in 2000?
Your answer should be very brief. 0.57. What is the ratio of the Prive value of exports (constant LCU) of Samoa in 1996 to that in 2000?
Make the answer very short. 0.9. What is the ratio of the Prive value of exports (constant LCU) in Benin in 1996 to that in 2001?
Provide a succinct answer. 1.12. What is the ratio of the Prive value of exports (constant LCU) in Haiti in 1996 to that in 2001?
Offer a very short reply. 0.65. What is the ratio of the Prive value of exports (constant LCU) of Samoa in 1996 to that in 2001?
Ensure brevity in your answer.  0.82. What is the ratio of the Prive value of exports (constant LCU) in Benin in 1997 to that in 1998?
Keep it short and to the point. 0.94. What is the ratio of the Prive value of exports (constant LCU) in Haiti in 1997 to that in 1998?
Your answer should be compact. 1. What is the ratio of the Prive value of exports (constant LCU) in Samoa in 1997 to that in 1998?
Provide a succinct answer. 0.85. What is the ratio of the Prive value of exports (constant LCU) in Benin in 1997 to that in 1999?
Offer a terse response. 1.16. What is the ratio of the Prive value of exports (constant LCU) of Haiti in 1997 to that in 1999?
Provide a short and direct response. 0.73. What is the ratio of the Prive value of exports (constant LCU) of Samoa in 1997 to that in 1999?
Provide a short and direct response. 0.83. What is the ratio of the Prive value of exports (constant LCU) in Benin in 1997 to that in 2000?
Provide a short and direct response. 1.24. What is the ratio of the Prive value of exports (constant LCU) in Haiti in 1997 to that in 2000?
Give a very brief answer. 0.62. What is the ratio of the Prive value of exports (constant LCU) in Samoa in 1997 to that in 2000?
Make the answer very short. 0.94. What is the ratio of the Prive value of exports (constant LCU) in Benin in 1997 to that in 2001?
Provide a short and direct response. 1.22. What is the ratio of the Prive value of exports (constant LCU) of Haiti in 1997 to that in 2001?
Ensure brevity in your answer.  0.7. What is the ratio of the Prive value of exports (constant LCU) of Samoa in 1997 to that in 2001?
Your answer should be compact. 0.86. What is the ratio of the Prive value of exports (constant LCU) in Benin in 1998 to that in 1999?
Provide a succinct answer. 1.24. What is the ratio of the Prive value of exports (constant LCU) in Haiti in 1998 to that in 1999?
Provide a short and direct response. 0.73. What is the ratio of the Prive value of exports (constant LCU) of Samoa in 1998 to that in 1999?
Provide a short and direct response. 0.97. What is the ratio of the Prive value of exports (constant LCU) in Benin in 1998 to that in 2000?
Provide a succinct answer. 1.32. What is the ratio of the Prive value of exports (constant LCU) in Haiti in 1998 to that in 2000?
Provide a succinct answer. 0.62. What is the ratio of the Prive value of exports (constant LCU) in Samoa in 1998 to that in 2000?
Provide a short and direct response. 1.1. What is the ratio of the Prive value of exports (constant LCU) in Benin in 1998 to that in 2001?
Offer a very short reply. 1.3. What is the ratio of the Prive value of exports (constant LCU) of Haiti in 1998 to that in 2001?
Your response must be concise. 0.7. What is the ratio of the Prive value of exports (constant LCU) in Samoa in 1998 to that in 2001?
Give a very brief answer. 1. What is the ratio of the Prive value of exports (constant LCU) in Benin in 1999 to that in 2000?
Offer a very short reply. 1.07. What is the ratio of the Prive value of exports (constant LCU) of Haiti in 1999 to that in 2000?
Your answer should be compact. 0.84. What is the ratio of the Prive value of exports (constant LCU) of Samoa in 1999 to that in 2000?
Your answer should be compact. 1.14. What is the ratio of the Prive value of exports (constant LCU) of Benin in 1999 to that in 2001?
Make the answer very short. 1.05. What is the ratio of the Prive value of exports (constant LCU) in Haiti in 1999 to that in 2001?
Your answer should be compact. 0.95. What is the ratio of the Prive value of exports (constant LCU) in Samoa in 1999 to that in 2001?
Give a very brief answer. 1.04. What is the ratio of the Prive value of exports (constant LCU) of Benin in 2000 to that in 2001?
Make the answer very short. 0.98. What is the ratio of the Prive value of exports (constant LCU) of Haiti in 2000 to that in 2001?
Ensure brevity in your answer.  1.13. What is the ratio of the Prive value of exports (constant LCU) of Samoa in 2000 to that in 2001?
Ensure brevity in your answer.  0.91. What is the difference between the highest and the second highest Prive value of exports (constant LCU) of Benin?
Your answer should be compact. 3.19e+1. What is the difference between the highest and the second highest Prive value of exports (constant LCU) of Haiti?
Give a very brief answer. 6.86e+08. What is the difference between the highest and the second highest Prive value of exports (constant LCU) of Samoa?
Provide a succinct answer. 9.18e+06. What is the difference between the highest and the lowest Prive value of exports (constant LCU) of Benin?
Your answer should be compact. 1.31e+11. What is the difference between the highest and the lowest Prive value of exports (constant LCU) of Haiti?
Your answer should be compact. 4.82e+09. What is the difference between the highest and the lowest Prive value of exports (constant LCU) in Samoa?
Offer a very short reply. 1.55e+08. 